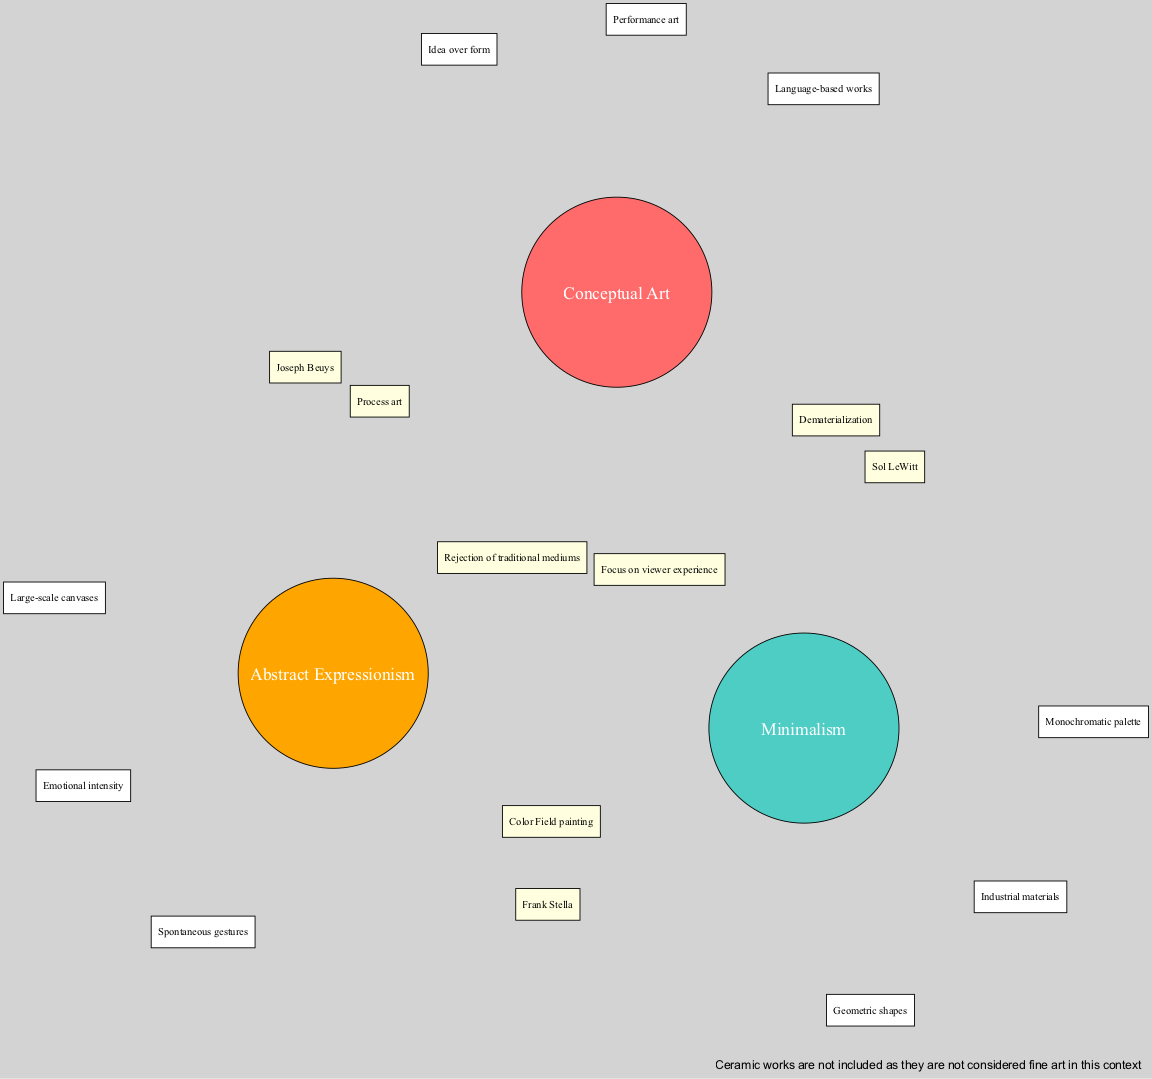What are the elements included in the Conceptual Art set? The "Conceptual Art" set has three specific elements: "Idea over form," "Language-based works," and "Performance art." These elements are listed directly under the Conceptual Art node in the diagram.
Answer: Idea over form, Language-based works, Performance art How many elements are listed under the Minimalism set? Under the "Minimalism" set, there are three elements: "Geometric shapes," "Monochromatic palette," and "Industrial materials." Counting these gives us a total of three elements.
Answer: 3 Which artist is associated with the intersection of Conceptual Art and Minimalism? In the intersection area between "Conceptual Art" and "Minimalism," the artist "Sol LeWitt" is specifically mentioned. This information indicates his importance in both movements.
Answer: Sol LeWitt What concept do all three sets share in their intersection? The intersection point of all three sets (Conceptual Art, Minimalism, and Abstract Expressionism) highlights the themes of "Rejection of traditional mediums" and "Focus on viewer experience." Both concepts indicate a shared philosophical viewpoint across the three art movements.
Answer: Rejection of traditional mediums, Focus on viewer experience How many total intersections are represented in the diagram? The diagram depicts four intersections: two between two sets (Conceptual Art and Minimalism; Minimalism and Abstract Expressionism; Conceptual Art and Abstract Expressionism) and one that includes all three sets. Therefore, summing these gives a total of four distinct intersections.
Answer: 4 What type of art is explicitly excluded from this diagram? The note at the bottom of the diagram states that "Ceramic works are not included as they are not considered fine art in this context." This exclusion clarifies the boundaries of the diagram’s focus on these three art movements.
Answer: Ceramic works Which term is used to describe the painting style connected to both Minimalism and Abstract Expressionism? Within the intersection of "Minimalism" and "Abstract Expressionism," the term "Color Field painting" is utilized, indicating a significant style that bridges these two movements.
Answer: Color Field painting How many total sets are illustrated in the diagram? There are three sets represented within the diagram, namely "Conceptual Art," "Minimalism," and "Abstract Expressionism." Counting these provides a straightforward answer to the inquiry regarding the total number of sets.
Answer: 3 